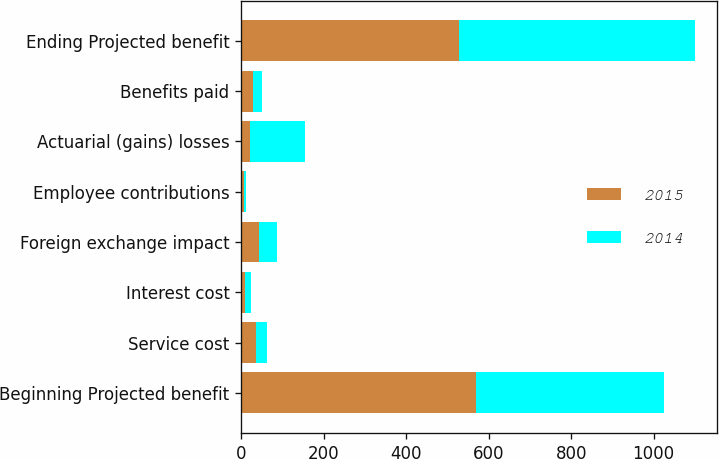Convert chart to OTSL. <chart><loc_0><loc_0><loc_500><loc_500><stacked_bar_chart><ecel><fcel>Beginning Projected benefit<fcel>Service cost<fcel>Interest cost<fcel>Foreign exchange impact<fcel>Employee contributions<fcel>Actuarial (gains) losses<fcel>Benefits paid<fcel>Ending Projected benefit<nl><fcel>2015<fcel>570<fcel>36<fcel>10<fcel>43<fcel>6<fcel>21<fcel>29<fcel>529<nl><fcel>2014<fcel>456<fcel>26<fcel>13<fcel>43<fcel>6<fcel>134<fcel>22<fcel>570<nl></chart> 